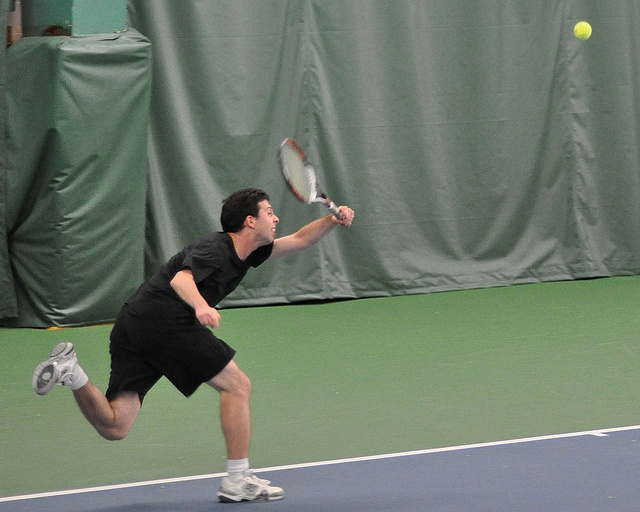Describe the objects in this image and their specific colors. I can see people in gray, black, and darkgray tones, tennis racket in gray, darkgray, and lightgray tones, and sports ball in gray, khaki, and olive tones in this image. 